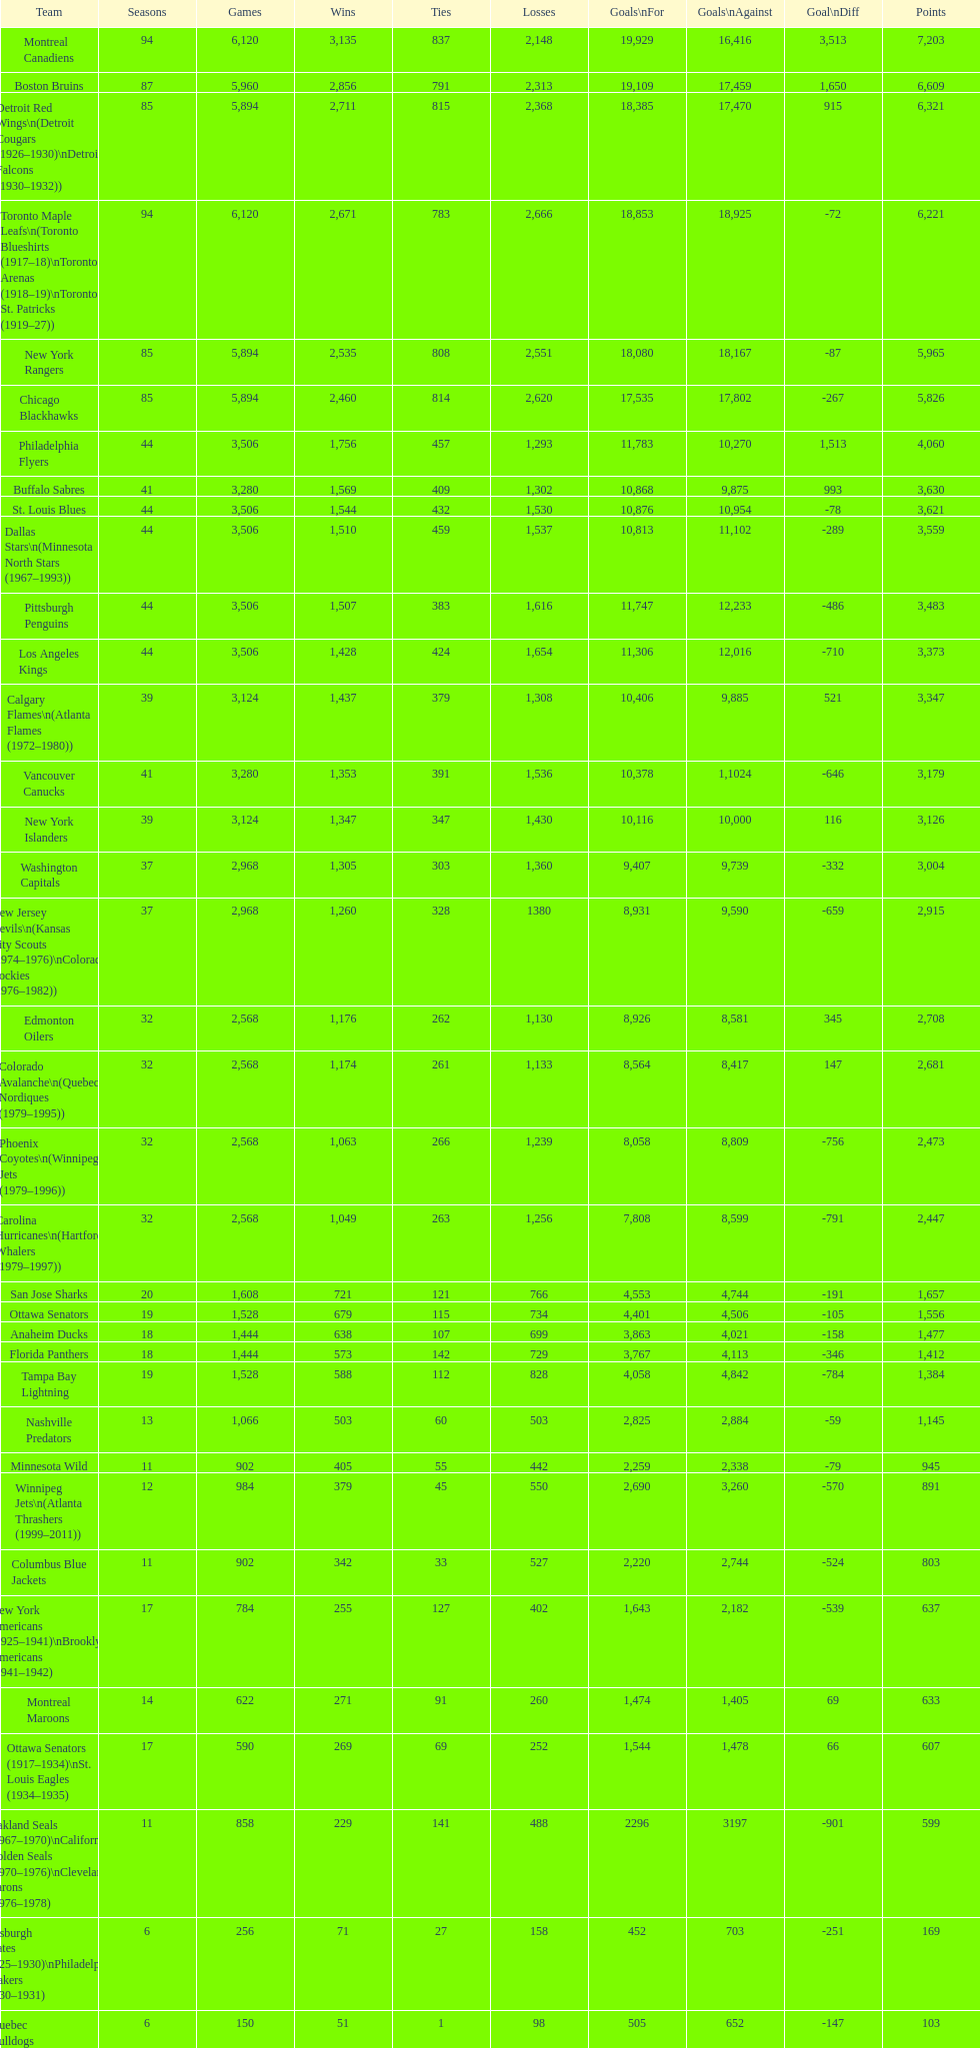What is the total number of points scored by the los angeles kings? 3,373. 